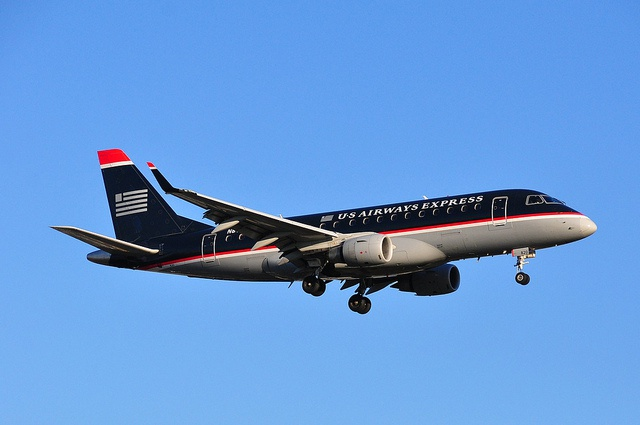Describe the objects in this image and their specific colors. I can see a airplane in gray, black, darkgray, and lightgray tones in this image. 